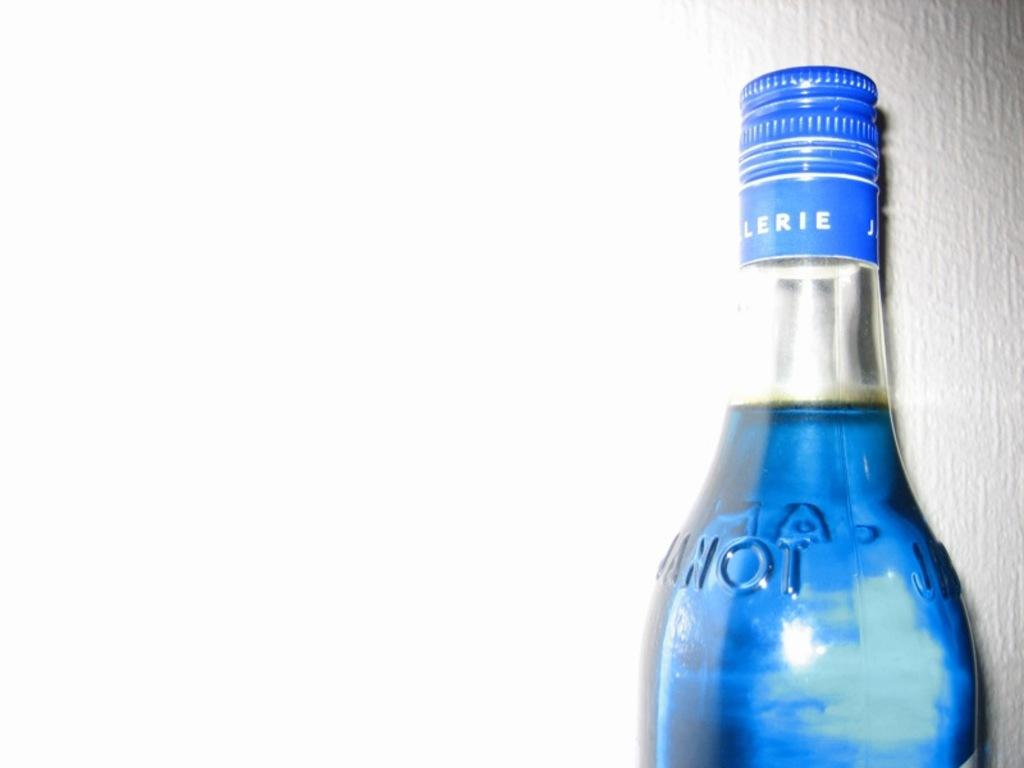<image>
Present a compact description of the photo's key features. Lerie is visible on the cap of a bottle. 